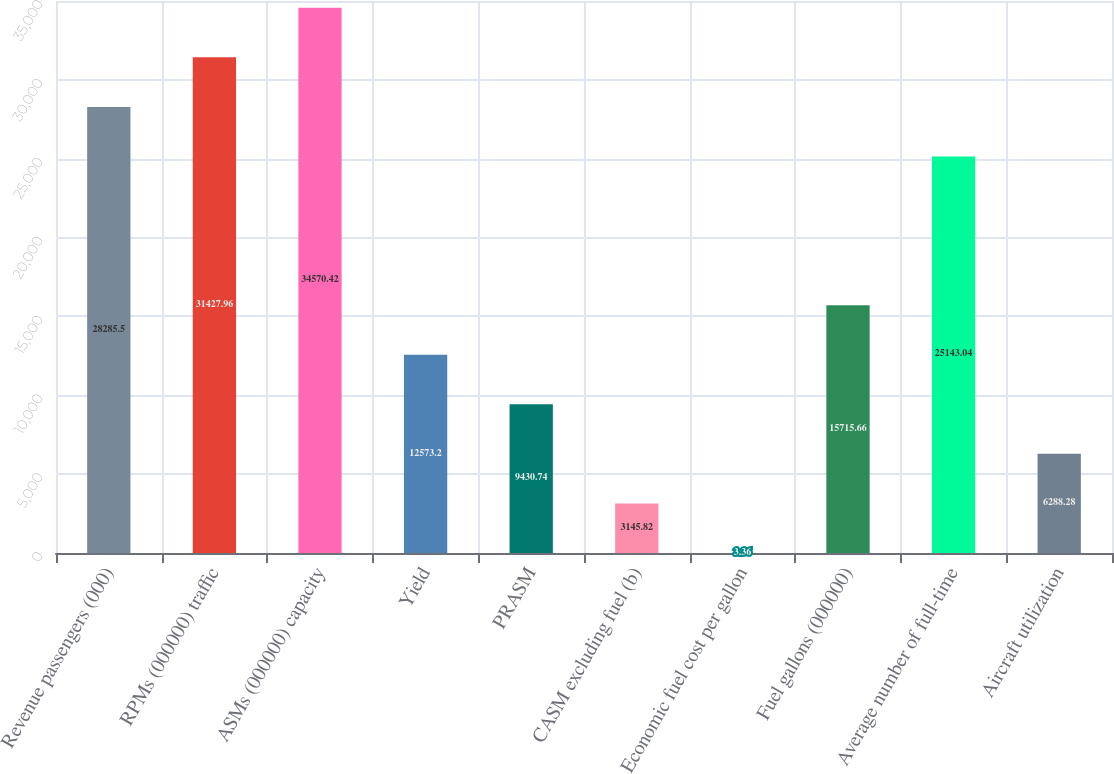Convert chart. <chart><loc_0><loc_0><loc_500><loc_500><bar_chart><fcel>Revenue passengers (000)<fcel>RPMs (000000) traffic<fcel>ASMs (000000) capacity<fcel>Yield<fcel>PRASM<fcel>CASM excluding fuel (b)<fcel>Economic fuel cost per gallon<fcel>Fuel gallons (000000)<fcel>Average number of full-time<fcel>Aircraft utilization<nl><fcel>28285.5<fcel>31428<fcel>34570.4<fcel>12573.2<fcel>9430.74<fcel>3145.82<fcel>3.36<fcel>15715.7<fcel>25143<fcel>6288.28<nl></chart> 